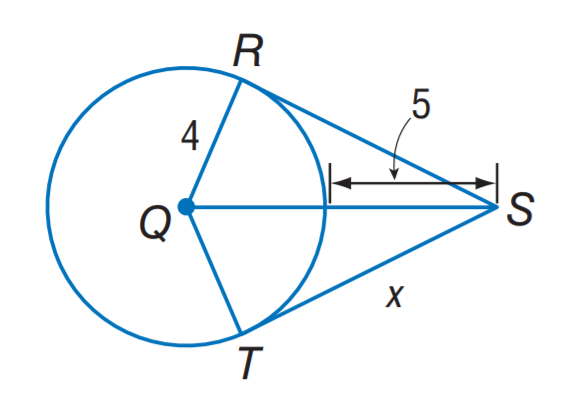Answer the mathemtical geometry problem and directly provide the correct option letter.
Question: The segment is tangent to the circle. Find x to the nearest hundredth.
Choices: A: 3.00 B: 4.03 C: 6.72 D: 8.06 D 